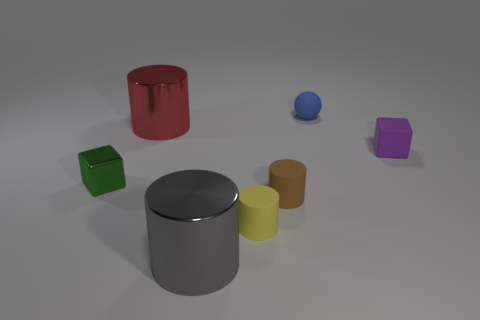Do the big gray cylinder that is in front of the brown cylinder and the green cube have the same material?
Provide a short and direct response. Yes. Are there any rubber objects of the same size as the red shiny thing?
Your response must be concise. No. Is the shape of the tiny yellow thing the same as the big object in front of the green block?
Your answer should be compact. Yes. There is a small rubber cylinder that is right of the small rubber cylinder that is in front of the brown thing; is there a small brown thing in front of it?
Keep it short and to the point. No. The brown thing has what size?
Your answer should be compact. Small. What number of other things are there of the same color as the sphere?
Your answer should be compact. 0. There is a big object behind the tiny green object; does it have the same shape as the purple thing?
Give a very brief answer. No. There is another metallic object that is the same shape as the purple thing; what color is it?
Offer a terse response. Green. Is there any other thing that has the same material as the tiny blue sphere?
Ensure brevity in your answer.  Yes. What size is the gray thing that is the same shape as the small brown object?
Offer a terse response. Large. 